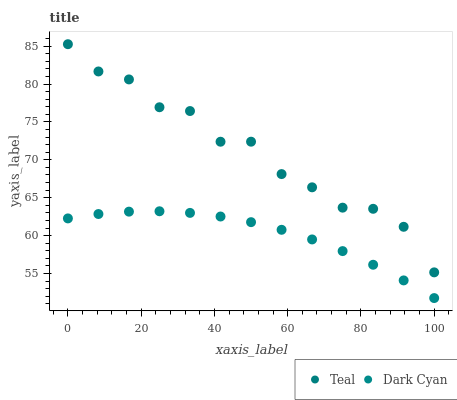Does Dark Cyan have the minimum area under the curve?
Answer yes or no. Yes. Does Teal have the maximum area under the curve?
Answer yes or no. Yes. Does Teal have the minimum area under the curve?
Answer yes or no. No. Is Dark Cyan the smoothest?
Answer yes or no. Yes. Is Teal the roughest?
Answer yes or no. Yes. Is Teal the smoothest?
Answer yes or no. No. Does Dark Cyan have the lowest value?
Answer yes or no. Yes. Does Teal have the lowest value?
Answer yes or no. No. Does Teal have the highest value?
Answer yes or no. Yes. Is Dark Cyan less than Teal?
Answer yes or no. Yes. Is Teal greater than Dark Cyan?
Answer yes or no. Yes. Does Dark Cyan intersect Teal?
Answer yes or no. No. 